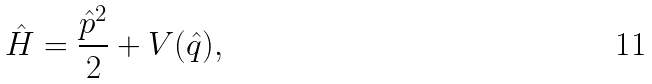Convert formula to latex. <formula><loc_0><loc_0><loc_500><loc_500>\hat { H } = \frac { { \hat { p } } ^ { 2 } } { 2 } + V ( \hat { q } ) ,</formula> 